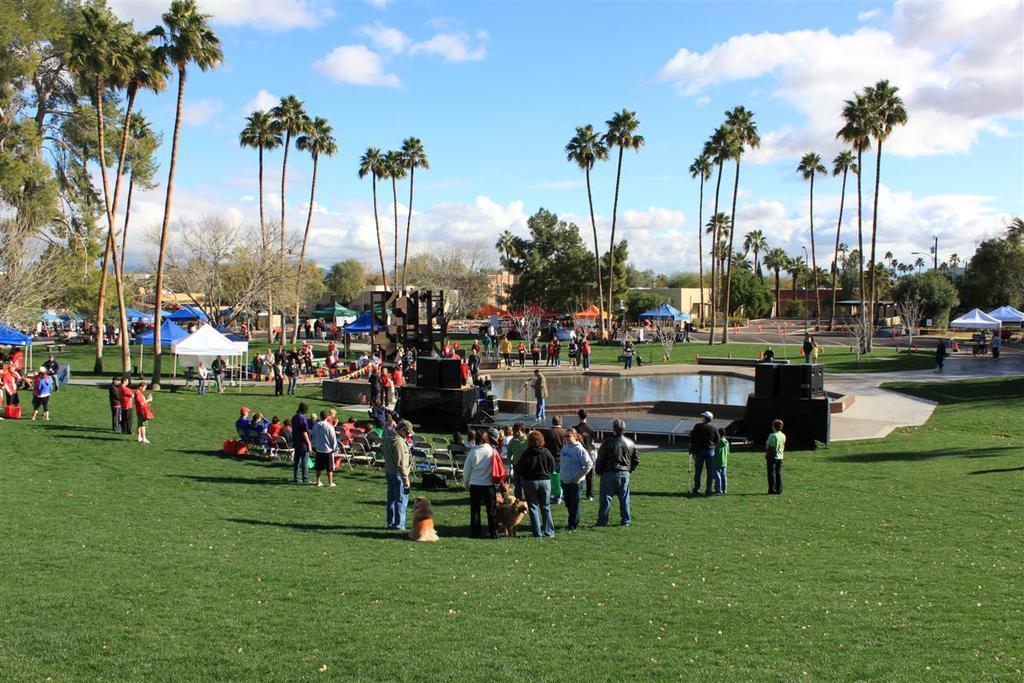In one or two sentences, can you explain what this image depicts? In this image there are many people and dogs standing on the ground. There is grass on the ground. In the center there there is the water. In the background there are tents, houses and trees. At the top there is the sky. 